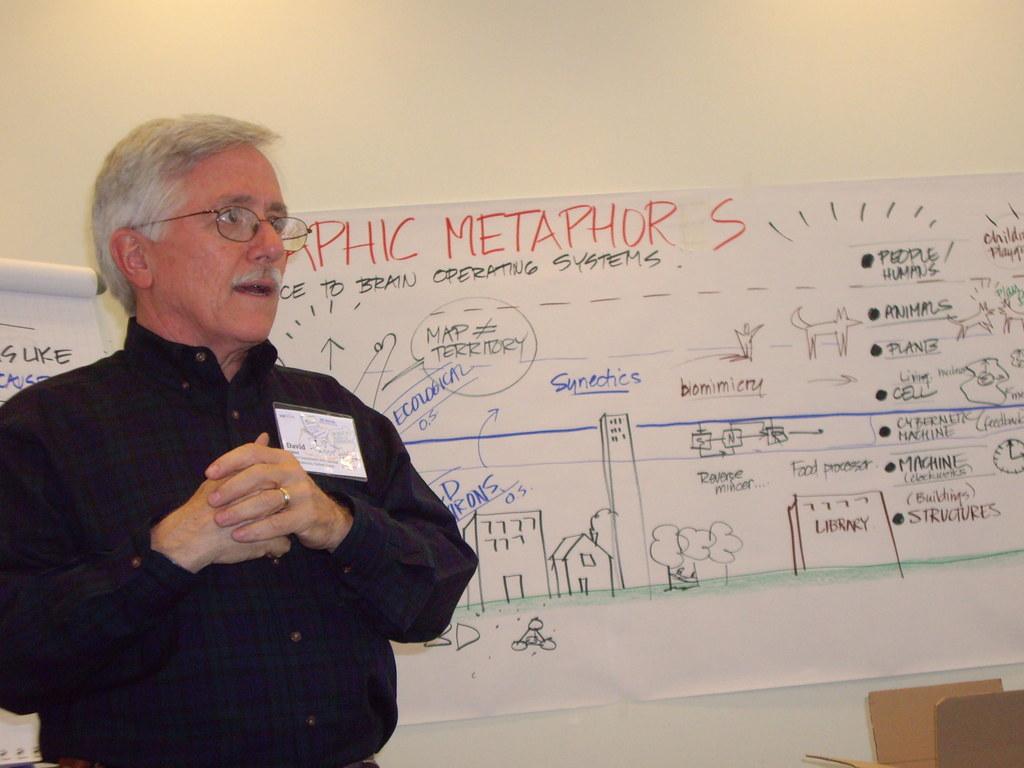What is speech about?
Offer a very short reply. Graphic metaphors. Are synetics mentioned?
Your answer should be compact. Yes. 